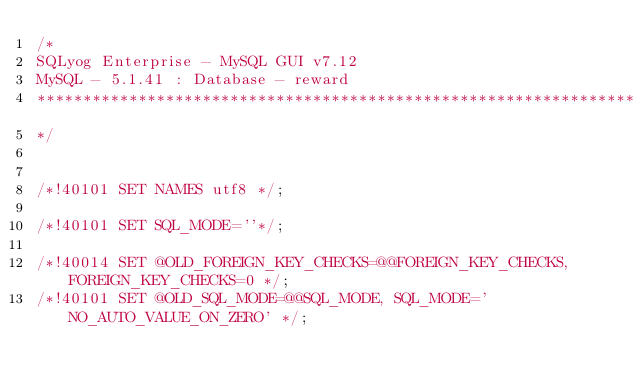Convert code to text. <code><loc_0><loc_0><loc_500><loc_500><_SQL_>/*
SQLyog Enterprise - MySQL GUI v7.12 
MySQL - 5.1.41 : Database - reward
*********************************************************************
*/

/*!40101 SET NAMES utf8 */;

/*!40101 SET SQL_MODE=''*/;

/*!40014 SET @OLD_FOREIGN_KEY_CHECKS=@@FOREIGN_KEY_CHECKS, FOREIGN_KEY_CHECKS=0 */;
/*!40101 SET @OLD_SQL_MODE=@@SQL_MODE, SQL_MODE='NO_AUTO_VALUE_ON_ZERO' */;
</code> 